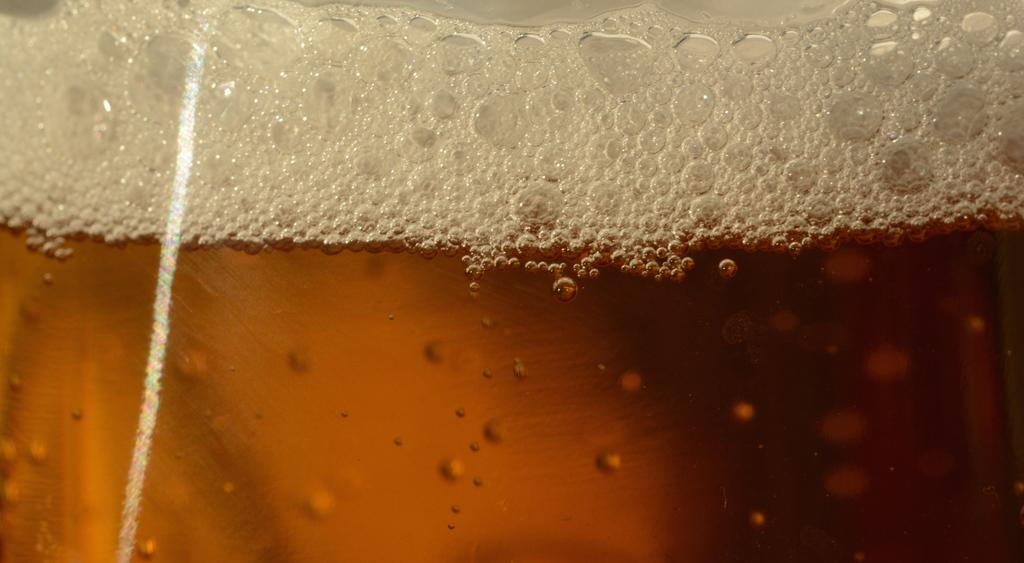What is the main subject of the image? The main subject of the image is a drink. What can be observed about the drink's appearance? The drink has bubbles and red and white colors. What type of string is used to create the bubbles in the drink? There is no string present in the image, and the bubbles are a natural part of the drink's appearance. How is the needle used to measure the drink's volume? There is no needle present in the image, and the drink's volume is not being measured. 